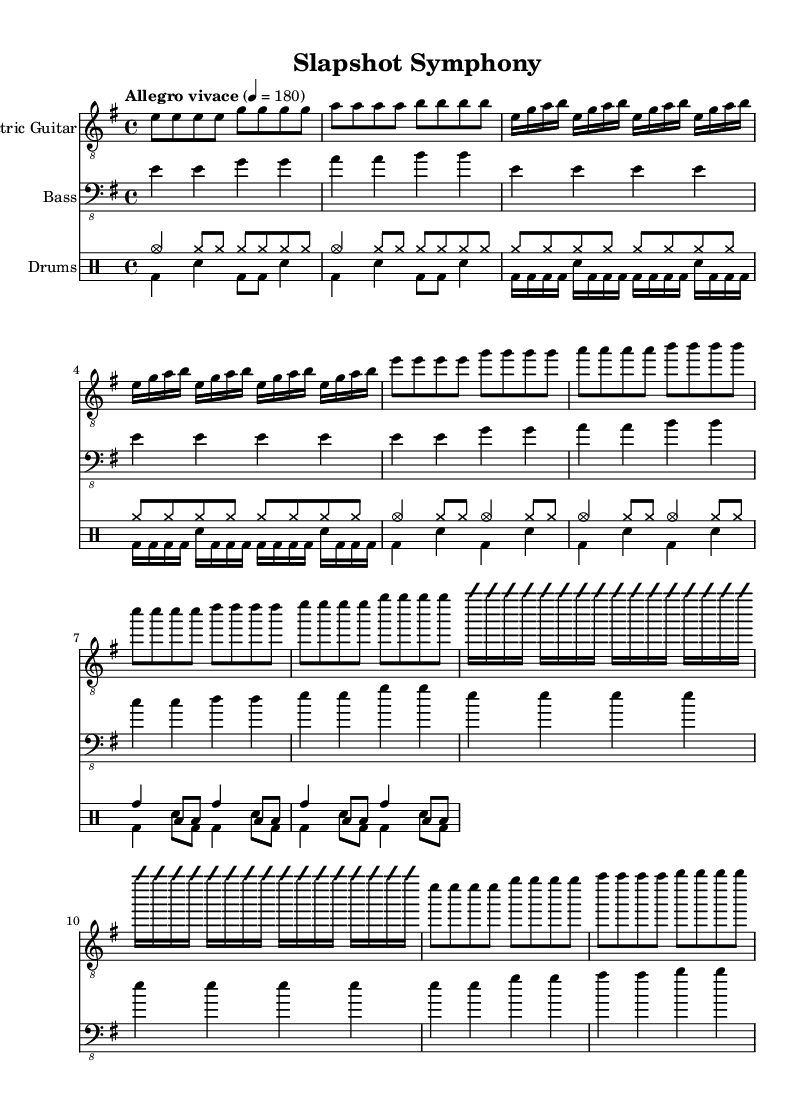What is the key signature of this music? The key signature indicates E minor, which has one sharp (F#). This can be confirmed by looking at the key signature at the beginning of the first staff.
Answer: E minor What is the time signature of the piece? The time signature is indicated as 4/4, which means there are four beats in each measure and the quarter note gets the beat. This information can be found at the beginning of the score.
Answer: 4/4 What is the tempo marking for the music? The tempo marking is "Allegro vivace," which typically indicates a fast and lively pace. The specific beat is set at 180 beats per minute, as shown in the tempo indication at the start of the score.
Answer: Allegro vivace How many measures are there in the intro? The intro consists of 4 measures, which can be counted by visualizing the notation and grouping the music into distinct measures. Each group of notes separated by vertical lines counts as a measure.
Answer: 4 What is the primary instrumentation used in this piece? The primary instrumentation consists of electric guitar, bass guitar, and drums, as indicated by the separate staffs labeled for each instrument at the beginning of the score.
Answer: Electric guitar, bass, drums What style of music does this piece represent? This piece represents the thrash metal style, characterized by fast tempos, aggressive guitar riffs, and emphatic drumming. This can be inferred from the tempo, the energy reflected in the music, and the overall structure typical of metal compositions.
Answer: Thrash metal How does the solo section differ from the verse section? The solo section employs improvisation with fast, high-energy notes, while the verse section uses a more repetitive and structured melody. This contrast can be noted by examining the notation and how it varies in complexity and style from the verse to the solo sections.
Answer: Improvisation vs. structured melody 